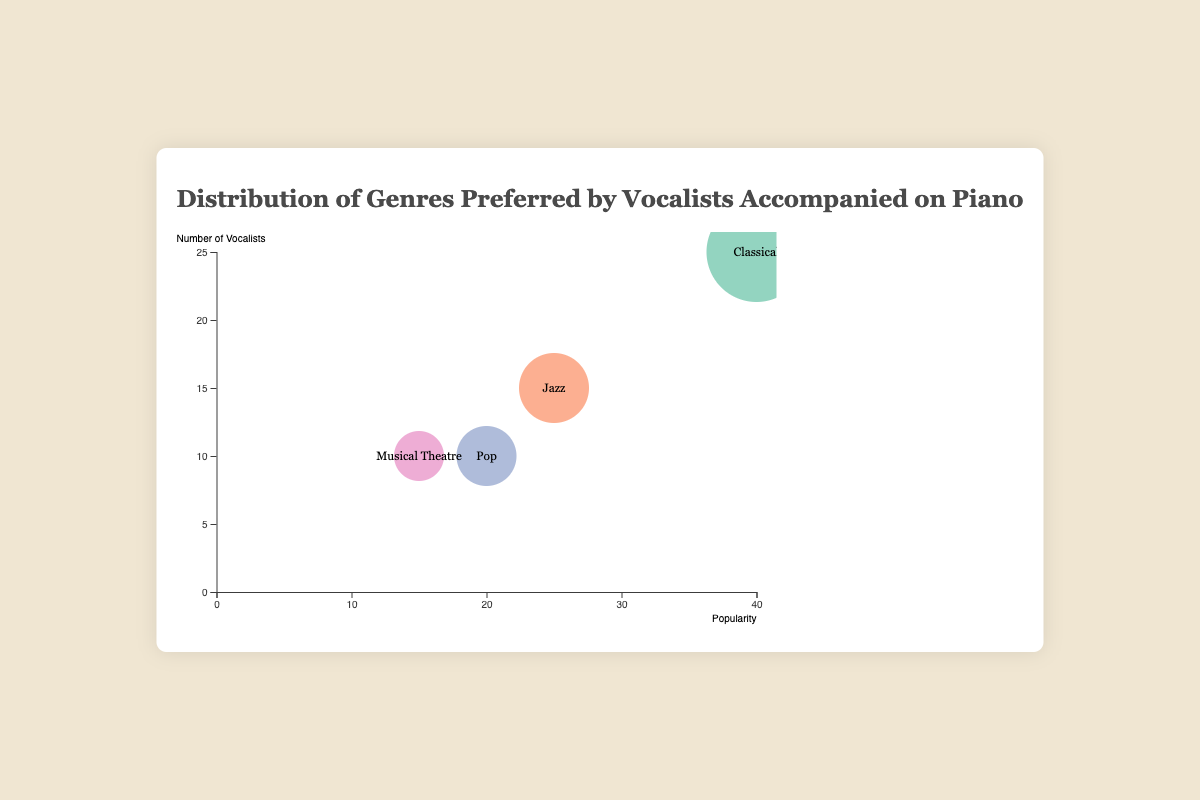What is the title of the bubble chart? The title of the chart is displayed at the top in a larger font size. It summarizes the content of the chart clearly.
Answer: Distribution of Genres Preferred by Vocalists Accompanied on Piano How many genres are shown in the chart? The chart displays four bubbles, each representing a different musical genre.
Answer: 4 Which genre has the largest bubble size? The size of the bubble represents the popularity. The genre with the largest bubble is Classical.
Answer: Classical Which genre has the least popularity? The smaller the bubble size, the lesser the popularity. Musical Theatre has the smallest bubble.
Answer: Musical Theatre Which genre has the highest number of vocalists? By looking at the y-axis values, Classical is plotted highest, indicating the highest number of vocalists.
Answer: Classical What is the popularity range for the genres displayed? The x-axis shows the popularity scale ranging from the minimum value of 0 to the maximum value of 40, based on the positioning of the bubbles.
Answer: 0 to 40 Compare the number of vocalists for Jazz and Pop. Which has more? Observing the y-axis, the Jazz bubble is positioned higher than the Pop bubble, indicating Jazz has more vocalists.
Answer: Jazz Sum the popularity values of Jazz and Pop. The popularity of Jazz is 25, and Pop is 20. Their sum is 25 + 20.
Answer: 45 Which genres have an equal number of vocalists? Both Pop and Musical Theatre have their bubbles positioned at the same height on the y-axis, indicating an equal number of vocalists (10).
Answer: Pop and Musical Theatre What is the difference in popularity between Classical and Musical Theatre? Classical has a popularity of 40, and Musical Theatre has 15. The difference is 40 - 15.
Answer: 25 